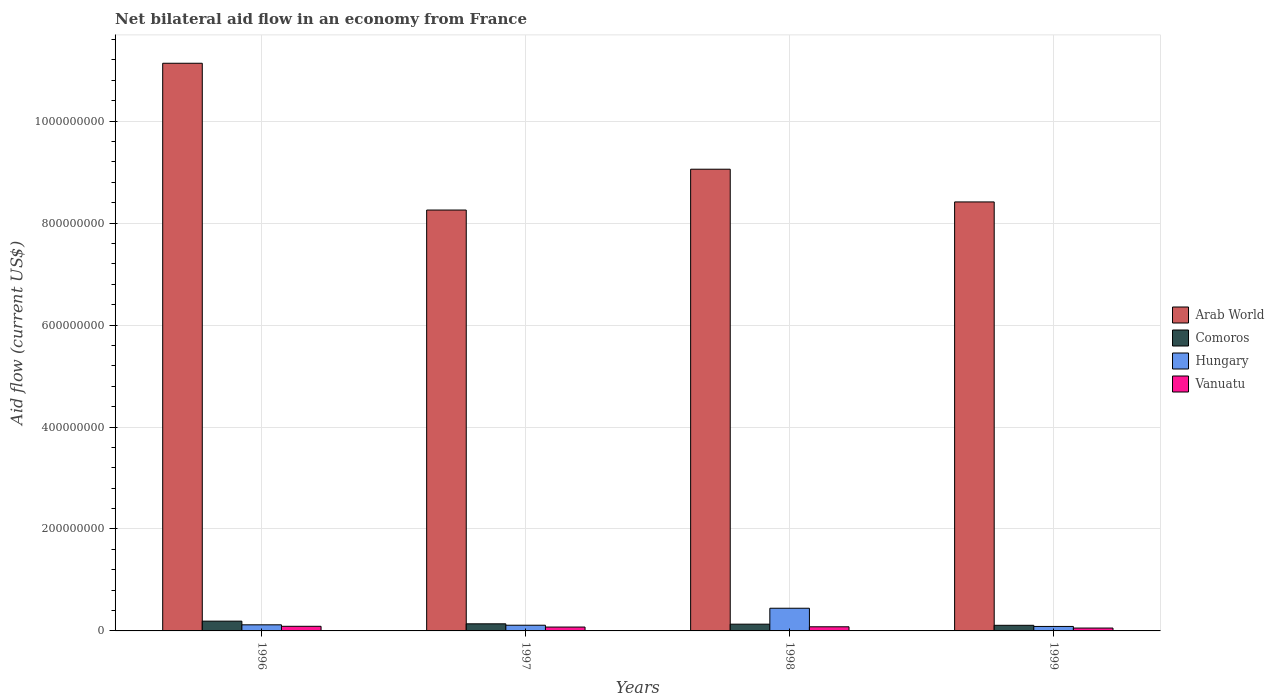How many groups of bars are there?
Make the answer very short. 4. Are the number of bars on each tick of the X-axis equal?
Ensure brevity in your answer.  Yes. How many bars are there on the 4th tick from the right?
Keep it short and to the point. 4. What is the label of the 1st group of bars from the left?
Your answer should be compact. 1996. In how many cases, is the number of bars for a given year not equal to the number of legend labels?
Your response must be concise. 0. What is the net bilateral aid flow in Arab World in 1998?
Provide a succinct answer. 9.06e+08. Across all years, what is the maximum net bilateral aid flow in Arab World?
Provide a succinct answer. 1.11e+09. Across all years, what is the minimum net bilateral aid flow in Arab World?
Offer a very short reply. 8.26e+08. In which year was the net bilateral aid flow in Vanuatu minimum?
Offer a terse response. 1999. What is the total net bilateral aid flow in Comoros in the graph?
Provide a short and direct response. 5.74e+07. What is the difference between the net bilateral aid flow in Comoros in 1997 and that in 1998?
Keep it short and to the point. 6.70e+05. What is the difference between the net bilateral aid flow in Hungary in 1997 and the net bilateral aid flow in Comoros in 1996?
Offer a terse response. -8.00e+06. What is the average net bilateral aid flow in Arab World per year?
Your answer should be compact. 9.22e+08. In the year 1998, what is the difference between the net bilateral aid flow in Vanuatu and net bilateral aid flow in Arab World?
Offer a very short reply. -8.98e+08. In how many years, is the net bilateral aid flow in Comoros greater than 1120000000 US$?
Your answer should be very brief. 0. What is the ratio of the net bilateral aid flow in Hungary in 1996 to that in 1999?
Keep it short and to the point. 1.37. What is the difference between the highest and the second highest net bilateral aid flow in Vanuatu?
Give a very brief answer. 9.50e+05. What is the difference between the highest and the lowest net bilateral aid flow in Hungary?
Keep it short and to the point. 3.57e+07. In how many years, is the net bilateral aid flow in Vanuatu greater than the average net bilateral aid flow in Vanuatu taken over all years?
Provide a short and direct response. 2. Is the sum of the net bilateral aid flow in Vanuatu in 1998 and 1999 greater than the maximum net bilateral aid flow in Hungary across all years?
Provide a short and direct response. No. Is it the case that in every year, the sum of the net bilateral aid flow in Arab World and net bilateral aid flow in Vanuatu is greater than the sum of net bilateral aid flow in Comoros and net bilateral aid flow in Hungary?
Keep it short and to the point. No. What does the 4th bar from the left in 1999 represents?
Your answer should be compact. Vanuatu. What does the 2nd bar from the right in 1998 represents?
Your answer should be compact. Hungary. Does the graph contain any zero values?
Your answer should be compact. No. Where does the legend appear in the graph?
Offer a terse response. Center right. How are the legend labels stacked?
Your answer should be compact. Vertical. What is the title of the graph?
Provide a short and direct response. Net bilateral aid flow in an economy from France. What is the Aid flow (current US$) in Arab World in 1996?
Keep it short and to the point. 1.11e+09. What is the Aid flow (current US$) in Comoros in 1996?
Offer a terse response. 1.92e+07. What is the Aid flow (current US$) in Hungary in 1996?
Provide a short and direct response. 1.20e+07. What is the Aid flow (current US$) in Vanuatu in 1996?
Your response must be concise. 9.07e+06. What is the Aid flow (current US$) of Arab World in 1997?
Your response must be concise. 8.26e+08. What is the Aid flow (current US$) of Comoros in 1997?
Ensure brevity in your answer.  1.39e+07. What is the Aid flow (current US$) in Hungary in 1997?
Your answer should be very brief. 1.12e+07. What is the Aid flow (current US$) in Vanuatu in 1997?
Offer a very short reply. 7.58e+06. What is the Aid flow (current US$) in Arab World in 1998?
Ensure brevity in your answer.  9.06e+08. What is the Aid flow (current US$) of Comoros in 1998?
Your answer should be compact. 1.33e+07. What is the Aid flow (current US$) of Hungary in 1998?
Offer a very short reply. 4.45e+07. What is the Aid flow (current US$) of Vanuatu in 1998?
Give a very brief answer. 8.12e+06. What is the Aid flow (current US$) of Arab World in 1999?
Keep it short and to the point. 8.42e+08. What is the Aid flow (current US$) of Comoros in 1999?
Offer a very short reply. 1.10e+07. What is the Aid flow (current US$) in Hungary in 1999?
Ensure brevity in your answer.  8.77e+06. What is the Aid flow (current US$) of Vanuatu in 1999?
Your answer should be very brief. 5.61e+06. Across all years, what is the maximum Aid flow (current US$) of Arab World?
Your answer should be compact. 1.11e+09. Across all years, what is the maximum Aid flow (current US$) of Comoros?
Your answer should be very brief. 1.92e+07. Across all years, what is the maximum Aid flow (current US$) in Hungary?
Make the answer very short. 4.45e+07. Across all years, what is the maximum Aid flow (current US$) of Vanuatu?
Provide a short and direct response. 9.07e+06. Across all years, what is the minimum Aid flow (current US$) in Arab World?
Offer a terse response. 8.26e+08. Across all years, what is the minimum Aid flow (current US$) of Comoros?
Your answer should be compact. 1.10e+07. Across all years, what is the minimum Aid flow (current US$) of Hungary?
Your answer should be compact. 8.77e+06. Across all years, what is the minimum Aid flow (current US$) of Vanuatu?
Your response must be concise. 5.61e+06. What is the total Aid flow (current US$) in Arab World in the graph?
Your answer should be very brief. 3.69e+09. What is the total Aid flow (current US$) of Comoros in the graph?
Keep it short and to the point. 5.74e+07. What is the total Aid flow (current US$) in Hungary in the graph?
Your response must be concise. 7.64e+07. What is the total Aid flow (current US$) of Vanuatu in the graph?
Provide a short and direct response. 3.04e+07. What is the difference between the Aid flow (current US$) of Arab World in 1996 and that in 1997?
Your answer should be very brief. 2.88e+08. What is the difference between the Aid flow (current US$) of Comoros in 1996 and that in 1997?
Your answer should be compact. 5.25e+06. What is the difference between the Aid flow (current US$) in Hungary in 1996 and that in 1997?
Make the answer very short. 8.00e+05. What is the difference between the Aid flow (current US$) in Vanuatu in 1996 and that in 1997?
Ensure brevity in your answer.  1.49e+06. What is the difference between the Aid flow (current US$) in Arab World in 1996 and that in 1998?
Keep it short and to the point. 2.08e+08. What is the difference between the Aid flow (current US$) in Comoros in 1996 and that in 1998?
Offer a terse response. 5.92e+06. What is the difference between the Aid flow (current US$) of Hungary in 1996 and that in 1998?
Provide a short and direct response. -3.25e+07. What is the difference between the Aid flow (current US$) in Vanuatu in 1996 and that in 1998?
Give a very brief answer. 9.50e+05. What is the difference between the Aid flow (current US$) of Arab World in 1996 and that in 1999?
Keep it short and to the point. 2.72e+08. What is the difference between the Aid flow (current US$) of Comoros in 1996 and that in 1999?
Ensure brevity in your answer.  8.15e+06. What is the difference between the Aid flow (current US$) of Hungary in 1996 and that in 1999?
Provide a succinct answer. 3.21e+06. What is the difference between the Aid flow (current US$) in Vanuatu in 1996 and that in 1999?
Make the answer very short. 3.46e+06. What is the difference between the Aid flow (current US$) in Arab World in 1997 and that in 1998?
Your response must be concise. -8.01e+07. What is the difference between the Aid flow (current US$) of Comoros in 1997 and that in 1998?
Provide a short and direct response. 6.70e+05. What is the difference between the Aid flow (current US$) in Hungary in 1997 and that in 1998?
Provide a succinct answer. -3.33e+07. What is the difference between the Aid flow (current US$) in Vanuatu in 1997 and that in 1998?
Offer a very short reply. -5.40e+05. What is the difference between the Aid flow (current US$) in Arab World in 1997 and that in 1999?
Offer a terse response. -1.59e+07. What is the difference between the Aid flow (current US$) of Comoros in 1997 and that in 1999?
Your answer should be compact. 2.90e+06. What is the difference between the Aid flow (current US$) of Hungary in 1997 and that in 1999?
Keep it short and to the point. 2.41e+06. What is the difference between the Aid flow (current US$) of Vanuatu in 1997 and that in 1999?
Your answer should be very brief. 1.97e+06. What is the difference between the Aid flow (current US$) of Arab World in 1998 and that in 1999?
Your answer should be compact. 6.42e+07. What is the difference between the Aid flow (current US$) in Comoros in 1998 and that in 1999?
Give a very brief answer. 2.23e+06. What is the difference between the Aid flow (current US$) in Hungary in 1998 and that in 1999?
Ensure brevity in your answer.  3.57e+07. What is the difference between the Aid flow (current US$) of Vanuatu in 1998 and that in 1999?
Keep it short and to the point. 2.51e+06. What is the difference between the Aid flow (current US$) in Arab World in 1996 and the Aid flow (current US$) in Comoros in 1997?
Offer a very short reply. 1.10e+09. What is the difference between the Aid flow (current US$) of Arab World in 1996 and the Aid flow (current US$) of Hungary in 1997?
Offer a terse response. 1.10e+09. What is the difference between the Aid flow (current US$) of Arab World in 1996 and the Aid flow (current US$) of Vanuatu in 1997?
Provide a short and direct response. 1.11e+09. What is the difference between the Aid flow (current US$) of Comoros in 1996 and the Aid flow (current US$) of Vanuatu in 1997?
Offer a terse response. 1.16e+07. What is the difference between the Aid flow (current US$) of Hungary in 1996 and the Aid flow (current US$) of Vanuatu in 1997?
Provide a short and direct response. 4.40e+06. What is the difference between the Aid flow (current US$) in Arab World in 1996 and the Aid flow (current US$) in Comoros in 1998?
Offer a terse response. 1.10e+09. What is the difference between the Aid flow (current US$) of Arab World in 1996 and the Aid flow (current US$) of Hungary in 1998?
Keep it short and to the point. 1.07e+09. What is the difference between the Aid flow (current US$) in Arab World in 1996 and the Aid flow (current US$) in Vanuatu in 1998?
Give a very brief answer. 1.11e+09. What is the difference between the Aid flow (current US$) in Comoros in 1996 and the Aid flow (current US$) in Hungary in 1998?
Keep it short and to the point. -2.53e+07. What is the difference between the Aid flow (current US$) of Comoros in 1996 and the Aid flow (current US$) of Vanuatu in 1998?
Offer a very short reply. 1.11e+07. What is the difference between the Aid flow (current US$) in Hungary in 1996 and the Aid flow (current US$) in Vanuatu in 1998?
Give a very brief answer. 3.86e+06. What is the difference between the Aid flow (current US$) of Arab World in 1996 and the Aid flow (current US$) of Comoros in 1999?
Keep it short and to the point. 1.10e+09. What is the difference between the Aid flow (current US$) of Arab World in 1996 and the Aid flow (current US$) of Hungary in 1999?
Your answer should be compact. 1.10e+09. What is the difference between the Aid flow (current US$) in Arab World in 1996 and the Aid flow (current US$) in Vanuatu in 1999?
Your answer should be compact. 1.11e+09. What is the difference between the Aid flow (current US$) of Comoros in 1996 and the Aid flow (current US$) of Hungary in 1999?
Give a very brief answer. 1.04e+07. What is the difference between the Aid flow (current US$) in Comoros in 1996 and the Aid flow (current US$) in Vanuatu in 1999?
Provide a succinct answer. 1.36e+07. What is the difference between the Aid flow (current US$) in Hungary in 1996 and the Aid flow (current US$) in Vanuatu in 1999?
Your answer should be very brief. 6.37e+06. What is the difference between the Aid flow (current US$) of Arab World in 1997 and the Aid flow (current US$) of Comoros in 1998?
Keep it short and to the point. 8.12e+08. What is the difference between the Aid flow (current US$) in Arab World in 1997 and the Aid flow (current US$) in Hungary in 1998?
Keep it short and to the point. 7.81e+08. What is the difference between the Aid flow (current US$) in Arab World in 1997 and the Aid flow (current US$) in Vanuatu in 1998?
Your response must be concise. 8.18e+08. What is the difference between the Aid flow (current US$) in Comoros in 1997 and the Aid flow (current US$) in Hungary in 1998?
Your response must be concise. -3.06e+07. What is the difference between the Aid flow (current US$) in Comoros in 1997 and the Aid flow (current US$) in Vanuatu in 1998?
Offer a terse response. 5.81e+06. What is the difference between the Aid flow (current US$) of Hungary in 1997 and the Aid flow (current US$) of Vanuatu in 1998?
Make the answer very short. 3.06e+06. What is the difference between the Aid flow (current US$) of Arab World in 1997 and the Aid flow (current US$) of Comoros in 1999?
Make the answer very short. 8.15e+08. What is the difference between the Aid flow (current US$) of Arab World in 1997 and the Aid flow (current US$) of Hungary in 1999?
Make the answer very short. 8.17e+08. What is the difference between the Aid flow (current US$) of Arab World in 1997 and the Aid flow (current US$) of Vanuatu in 1999?
Offer a terse response. 8.20e+08. What is the difference between the Aid flow (current US$) in Comoros in 1997 and the Aid flow (current US$) in Hungary in 1999?
Keep it short and to the point. 5.16e+06. What is the difference between the Aid flow (current US$) of Comoros in 1997 and the Aid flow (current US$) of Vanuatu in 1999?
Your answer should be very brief. 8.32e+06. What is the difference between the Aid flow (current US$) in Hungary in 1997 and the Aid flow (current US$) in Vanuatu in 1999?
Provide a short and direct response. 5.57e+06. What is the difference between the Aid flow (current US$) in Arab World in 1998 and the Aid flow (current US$) in Comoros in 1999?
Your answer should be compact. 8.95e+08. What is the difference between the Aid flow (current US$) in Arab World in 1998 and the Aid flow (current US$) in Hungary in 1999?
Provide a succinct answer. 8.97e+08. What is the difference between the Aid flow (current US$) in Arab World in 1998 and the Aid flow (current US$) in Vanuatu in 1999?
Offer a very short reply. 9.00e+08. What is the difference between the Aid flow (current US$) of Comoros in 1998 and the Aid flow (current US$) of Hungary in 1999?
Make the answer very short. 4.49e+06. What is the difference between the Aid flow (current US$) in Comoros in 1998 and the Aid flow (current US$) in Vanuatu in 1999?
Keep it short and to the point. 7.65e+06. What is the difference between the Aid flow (current US$) of Hungary in 1998 and the Aid flow (current US$) of Vanuatu in 1999?
Give a very brief answer. 3.89e+07. What is the average Aid flow (current US$) of Arab World per year?
Your answer should be very brief. 9.22e+08. What is the average Aid flow (current US$) of Comoros per year?
Give a very brief answer. 1.44e+07. What is the average Aid flow (current US$) of Hungary per year?
Keep it short and to the point. 1.91e+07. What is the average Aid flow (current US$) in Vanuatu per year?
Your response must be concise. 7.60e+06. In the year 1996, what is the difference between the Aid flow (current US$) in Arab World and Aid flow (current US$) in Comoros?
Your answer should be very brief. 1.09e+09. In the year 1996, what is the difference between the Aid flow (current US$) of Arab World and Aid flow (current US$) of Hungary?
Offer a very short reply. 1.10e+09. In the year 1996, what is the difference between the Aid flow (current US$) of Arab World and Aid flow (current US$) of Vanuatu?
Your answer should be very brief. 1.10e+09. In the year 1996, what is the difference between the Aid flow (current US$) in Comoros and Aid flow (current US$) in Hungary?
Offer a terse response. 7.20e+06. In the year 1996, what is the difference between the Aid flow (current US$) in Comoros and Aid flow (current US$) in Vanuatu?
Keep it short and to the point. 1.01e+07. In the year 1996, what is the difference between the Aid flow (current US$) in Hungary and Aid flow (current US$) in Vanuatu?
Your answer should be compact. 2.91e+06. In the year 1997, what is the difference between the Aid flow (current US$) in Arab World and Aid flow (current US$) in Comoros?
Ensure brevity in your answer.  8.12e+08. In the year 1997, what is the difference between the Aid flow (current US$) in Arab World and Aid flow (current US$) in Hungary?
Your answer should be compact. 8.14e+08. In the year 1997, what is the difference between the Aid flow (current US$) in Arab World and Aid flow (current US$) in Vanuatu?
Offer a terse response. 8.18e+08. In the year 1997, what is the difference between the Aid flow (current US$) in Comoros and Aid flow (current US$) in Hungary?
Your answer should be very brief. 2.75e+06. In the year 1997, what is the difference between the Aid flow (current US$) in Comoros and Aid flow (current US$) in Vanuatu?
Give a very brief answer. 6.35e+06. In the year 1997, what is the difference between the Aid flow (current US$) of Hungary and Aid flow (current US$) of Vanuatu?
Provide a short and direct response. 3.60e+06. In the year 1998, what is the difference between the Aid flow (current US$) of Arab World and Aid flow (current US$) of Comoros?
Make the answer very short. 8.92e+08. In the year 1998, what is the difference between the Aid flow (current US$) of Arab World and Aid flow (current US$) of Hungary?
Ensure brevity in your answer.  8.61e+08. In the year 1998, what is the difference between the Aid flow (current US$) in Arab World and Aid flow (current US$) in Vanuatu?
Your answer should be very brief. 8.98e+08. In the year 1998, what is the difference between the Aid flow (current US$) in Comoros and Aid flow (current US$) in Hungary?
Offer a very short reply. -3.12e+07. In the year 1998, what is the difference between the Aid flow (current US$) in Comoros and Aid flow (current US$) in Vanuatu?
Keep it short and to the point. 5.14e+06. In the year 1998, what is the difference between the Aid flow (current US$) of Hungary and Aid flow (current US$) of Vanuatu?
Your answer should be compact. 3.64e+07. In the year 1999, what is the difference between the Aid flow (current US$) in Arab World and Aid flow (current US$) in Comoros?
Offer a terse response. 8.31e+08. In the year 1999, what is the difference between the Aid flow (current US$) of Arab World and Aid flow (current US$) of Hungary?
Provide a short and direct response. 8.33e+08. In the year 1999, what is the difference between the Aid flow (current US$) in Arab World and Aid flow (current US$) in Vanuatu?
Provide a succinct answer. 8.36e+08. In the year 1999, what is the difference between the Aid flow (current US$) in Comoros and Aid flow (current US$) in Hungary?
Offer a very short reply. 2.26e+06. In the year 1999, what is the difference between the Aid flow (current US$) of Comoros and Aid flow (current US$) of Vanuatu?
Provide a short and direct response. 5.42e+06. In the year 1999, what is the difference between the Aid flow (current US$) in Hungary and Aid flow (current US$) in Vanuatu?
Keep it short and to the point. 3.16e+06. What is the ratio of the Aid flow (current US$) of Arab World in 1996 to that in 1997?
Offer a very short reply. 1.35. What is the ratio of the Aid flow (current US$) of Comoros in 1996 to that in 1997?
Make the answer very short. 1.38. What is the ratio of the Aid flow (current US$) in Hungary in 1996 to that in 1997?
Provide a short and direct response. 1.07. What is the ratio of the Aid flow (current US$) in Vanuatu in 1996 to that in 1997?
Your response must be concise. 1.2. What is the ratio of the Aid flow (current US$) of Arab World in 1996 to that in 1998?
Your answer should be compact. 1.23. What is the ratio of the Aid flow (current US$) in Comoros in 1996 to that in 1998?
Provide a succinct answer. 1.45. What is the ratio of the Aid flow (current US$) of Hungary in 1996 to that in 1998?
Keep it short and to the point. 0.27. What is the ratio of the Aid flow (current US$) in Vanuatu in 1996 to that in 1998?
Your answer should be very brief. 1.12. What is the ratio of the Aid flow (current US$) in Arab World in 1996 to that in 1999?
Your answer should be very brief. 1.32. What is the ratio of the Aid flow (current US$) in Comoros in 1996 to that in 1999?
Keep it short and to the point. 1.74. What is the ratio of the Aid flow (current US$) of Hungary in 1996 to that in 1999?
Provide a short and direct response. 1.37. What is the ratio of the Aid flow (current US$) in Vanuatu in 1996 to that in 1999?
Give a very brief answer. 1.62. What is the ratio of the Aid flow (current US$) in Arab World in 1997 to that in 1998?
Your response must be concise. 0.91. What is the ratio of the Aid flow (current US$) of Comoros in 1997 to that in 1998?
Offer a very short reply. 1.05. What is the ratio of the Aid flow (current US$) of Hungary in 1997 to that in 1998?
Offer a very short reply. 0.25. What is the ratio of the Aid flow (current US$) of Vanuatu in 1997 to that in 1998?
Your answer should be compact. 0.93. What is the ratio of the Aid flow (current US$) in Arab World in 1997 to that in 1999?
Keep it short and to the point. 0.98. What is the ratio of the Aid flow (current US$) in Comoros in 1997 to that in 1999?
Make the answer very short. 1.26. What is the ratio of the Aid flow (current US$) of Hungary in 1997 to that in 1999?
Your answer should be compact. 1.27. What is the ratio of the Aid flow (current US$) in Vanuatu in 1997 to that in 1999?
Provide a short and direct response. 1.35. What is the ratio of the Aid flow (current US$) in Arab World in 1998 to that in 1999?
Your answer should be compact. 1.08. What is the ratio of the Aid flow (current US$) in Comoros in 1998 to that in 1999?
Your answer should be very brief. 1.2. What is the ratio of the Aid flow (current US$) in Hungary in 1998 to that in 1999?
Ensure brevity in your answer.  5.07. What is the ratio of the Aid flow (current US$) of Vanuatu in 1998 to that in 1999?
Your answer should be compact. 1.45. What is the difference between the highest and the second highest Aid flow (current US$) in Arab World?
Your answer should be compact. 2.08e+08. What is the difference between the highest and the second highest Aid flow (current US$) in Comoros?
Offer a terse response. 5.25e+06. What is the difference between the highest and the second highest Aid flow (current US$) in Hungary?
Keep it short and to the point. 3.25e+07. What is the difference between the highest and the second highest Aid flow (current US$) of Vanuatu?
Ensure brevity in your answer.  9.50e+05. What is the difference between the highest and the lowest Aid flow (current US$) in Arab World?
Give a very brief answer. 2.88e+08. What is the difference between the highest and the lowest Aid flow (current US$) of Comoros?
Provide a short and direct response. 8.15e+06. What is the difference between the highest and the lowest Aid flow (current US$) in Hungary?
Give a very brief answer. 3.57e+07. What is the difference between the highest and the lowest Aid flow (current US$) in Vanuatu?
Your response must be concise. 3.46e+06. 